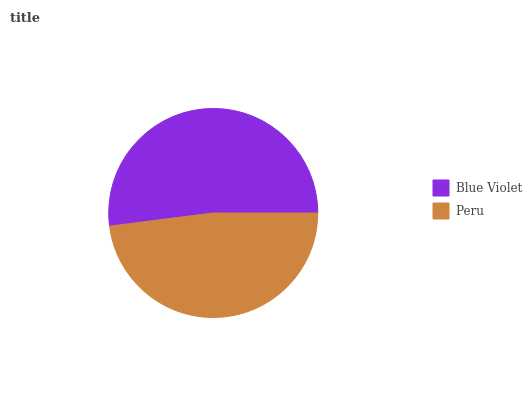Is Peru the minimum?
Answer yes or no. Yes. Is Blue Violet the maximum?
Answer yes or no. Yes. Is Peru the maximum?
Answer yes or no. No. Is Blue Violet greater than Peru?
Answer yes or no. Yes. Is Peru less than Blue Violet?
Answer yes or no. Yes. Is Peru greater than Blue Violet?
Answer yes or no. No. Is Blue Violet less than Peru?
Answer yes or no. No. Is Blue Violet the high median?
Answer yes or no. Yes. Is Peru the low median?
Answer yes or no. Yes. Is Peru the high median?
Answer yes or no. No. Is Blue Violet the low median?
Answer yes or no. No. 